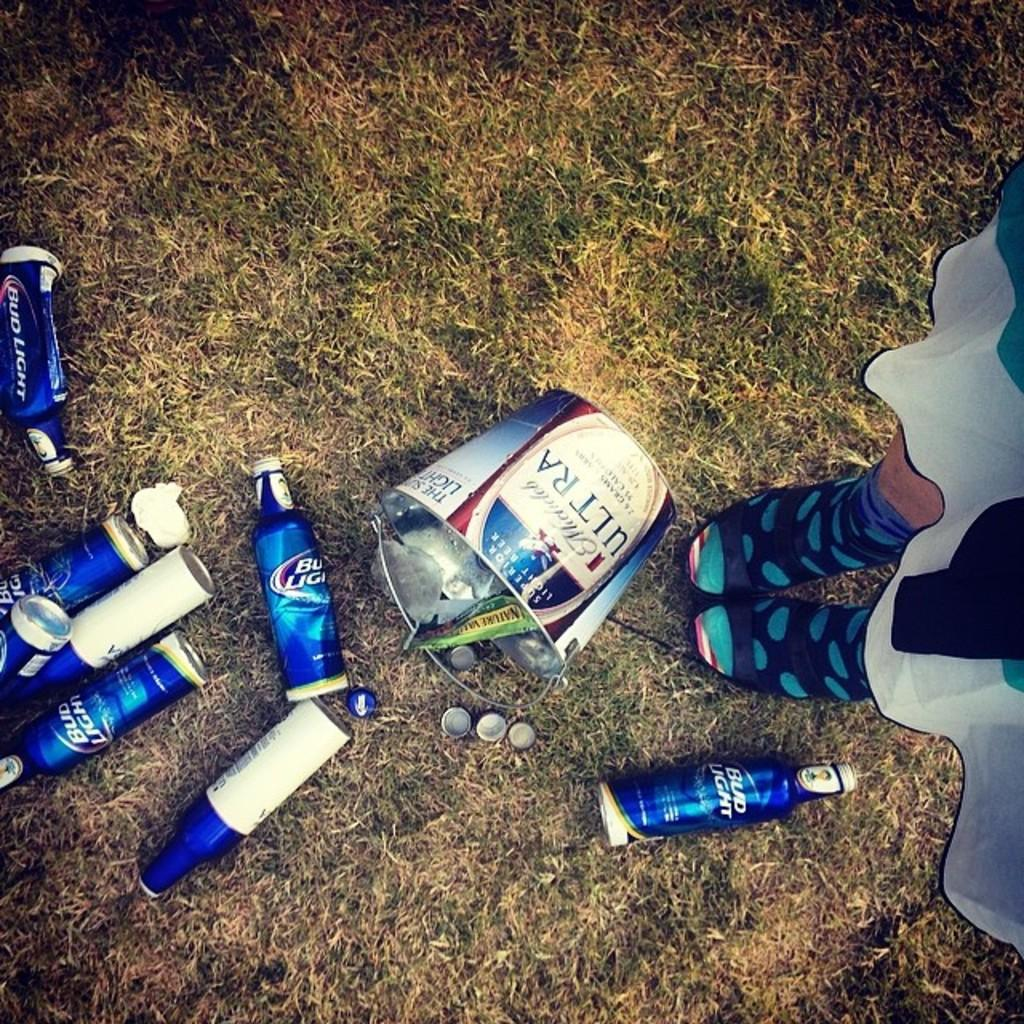<image>
Summarize the visual content of the image. A spilled Bud Light bucket and half a dozen Bud Light bottles lie on the ground. 